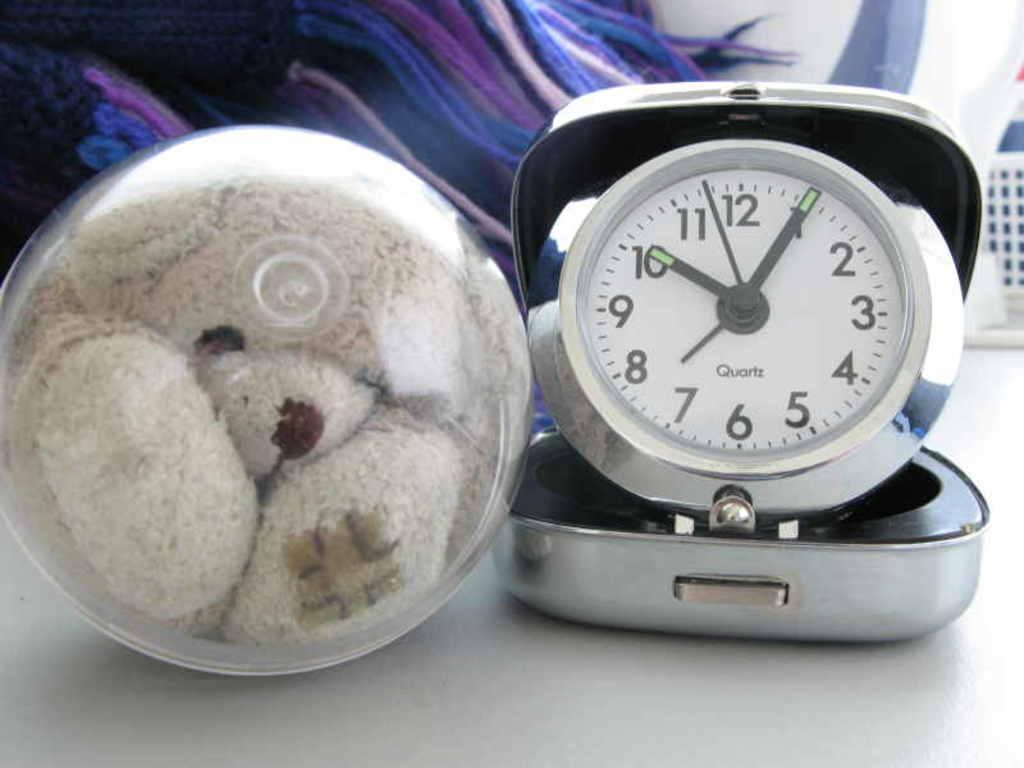<image>
Create a compact narrative representing the image presented. A toy bear in a plastic ball next to a Quartz clock. 